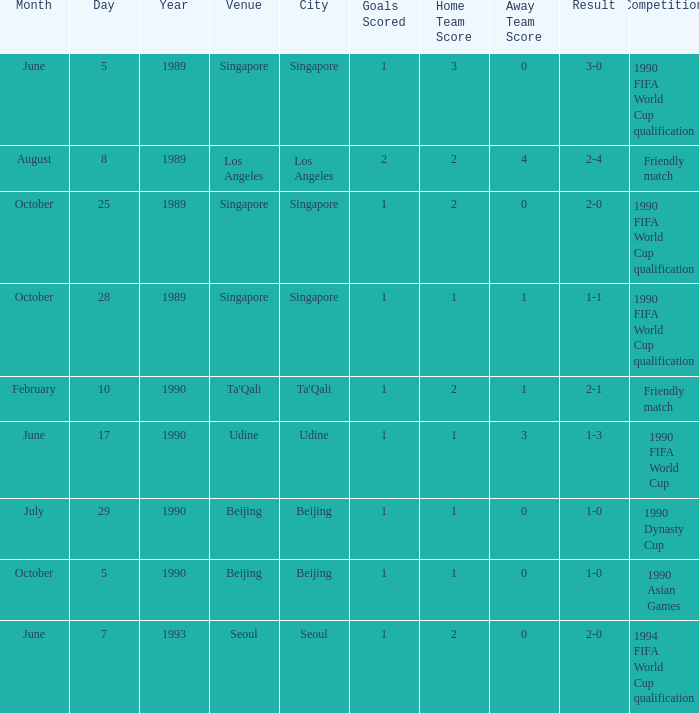What was the total score of the match that ended 3-0? 1 goal. Can you parse all the data within this table? {'header': ['Month', 'Day', 'Year', 'Venue', 'City', 'Goals Scored', 'Home Team Score', 'Away Team Score', 'Result', 'Competition'], 'rows': [['June', '5', '1989', 'Singapore', 'Singapore', '1', '3', '0', '3-0', '1990 FIFA World Cup qualification'], ['August', '8', '1989', 'Los Angeles', 'Los Angeles', '2', '2', '4', '2-4', 'Friendly match'], ['October', '25', '1989', 'Singapore', 'Singapore', '1', '2', '0', '2-0', '1990 FIFA World Cup qualification'], ['October', '28', '1989', 'Singapore', 'Singapore', '1', '1', '1', '1-1', '1990 FIFA World Cup qualification'], ['February', '10', '1990', "Ta'Qali", "Ta'Qali", '1', '2', '1', '2-1', 'Friendly match'], ['June', '17', '1990', 'Udine', 'Udine', '1', '1', '3', '1-3', '1990 FIFA World Cup'], ['July', '29', '1990', 'Beijing', 'Beijing', '1', '1', '0', '1-0', '1990 Dynasty Cup'], ['October', '5', '1990', 'Beijing', 'Beijing', '1', '1', '0', '1-0', '1990 Asian Games'], ['June', '7', '1993', 'Seoul', 'Seoul', '1', '2', '0', '2-0', '1994 FIFA World Cup qualification']]} 